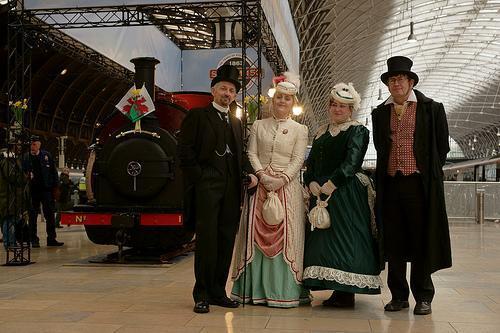How many people are wearing white hats in the picture?
Give a very brief answer. 2. 